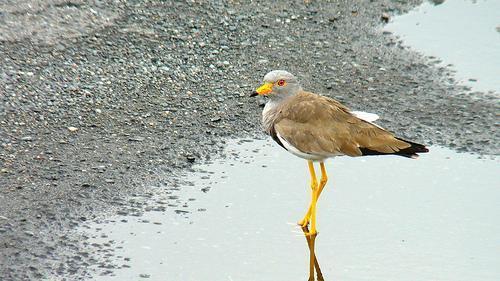How many birds are there?
Give a very brief answer. 1. 